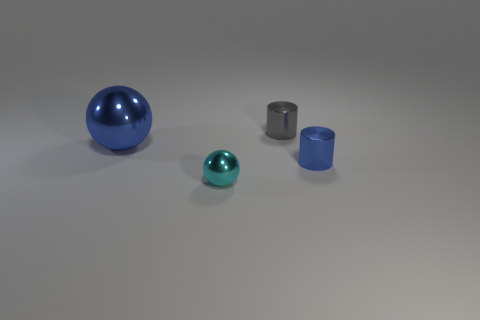Are there the same number of tiny gray metal cylinders that are on the left side of the large ball and tiny metallic spheres?
Provide a short and direct response. No. Are there any other things that are the same size as the gray metal cylinder?
Offer a very short reply. Yes. How many things are tiny gray shiny cylinders or cyan things?
Make the answer very short. 2. What is the shape of the blue thing that is the same material as the blue sphere?
Offer a terse response. Cylinder. How big is the blue object that is in front of the metallic ball on the left side of the cyan metal sphere?
Your response must be concise. Small. How many large things are balls or red shiny cubes?
Offer a terse response. 1. What number of other things are there of the same color as the small ball?
Provide a short and direct response. 0. Do the blue object that is on the left side of the tiny cyan shiny ball and the cylinder to the left of the small blue shiny cylinder have the same size?
Keep it short and to the point. No. Are there more blue objects that are on the right side of the cyan sphere than gray metal things that are to the left of the gray cylinder?
Offer a very short reply. Yes. The tiny thing behind the object that is left of the small metal ball is what color?
Provide a short and direct response. Gray. 